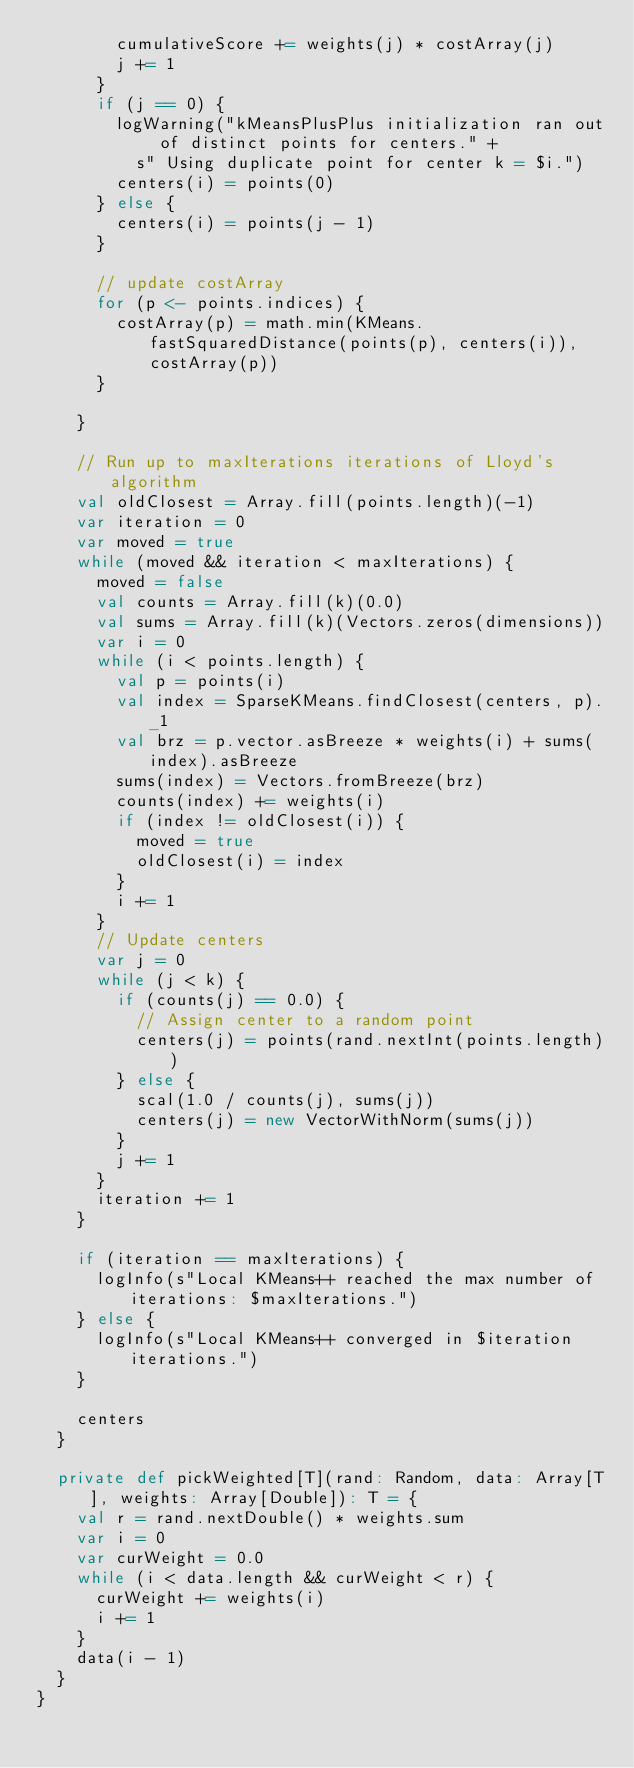<code> <loc_0><loc_0><loc_500><loc_500><_Scala_>        cumulativeScore += weights(j) * costArray(j)
        j += 1
      }
      if (j == 0) {
        logWarning("kMeansPlusPlus initialization ran out of distinct points for centers." +
          s" Using duplicate point for center k = $i.")
        centers(i) = points(0)
      } else {
        centers(i) = points(j - 1)
      }

      // update costArray
      for (p <- points.indices) {
        costArray(p) = math.min(KMeans.fastSquaredDistance(points(p), centers(i)), costArray(p))
      }

    }

    // Run up to maxIterations iterations of Lloyd's algorithm
    val oldClosest = Array.fill(points.length)(-1)
    var iteration = 0
    var moved = true
    while (moved && iteration < maxIterations) {
      moved = false
      val counts = Array.fill(k)(0.0)
      val sums = Array.fill(k)(Vectors.zeros(dimensions))
      var i = 0
      while (i < points.length) {
        val p = points(i)
        val index = SparseKMeans.findClosest(centers, p)._1
        val brz = p.vector.asBreeze * weights(i) + sums(index).asBreeze
        sums(index) = Vectors.fromBreeze(brz)
        counts(index) += weights(i)
        if (index != oldClosest(i)) {
          moved = true
          oldClosest(i) = index
        }
        i += 1
      }
      // Update centers
      var j = 0
      while (j < k) {
        if (counts(j) == 0.0) {
          // Assign center to a random point
          centers(j) = points(rand.nextInt(points.length))
        } else {
          scal(1.0 / counts(j), sums(j))
          centers(j) = new VectorWithNorm(sums(j))
        }
        j += 1
      }
      iteration += 1
    }

    if (iteration == maxIterations) {
      logInfo(s"Local KMeans++ reached the max number of iterations: $maxIterations.")
    } else {
      logInfo(s"Local KMeans++ converged in $iteration iterations.")
    }

    centers
  }

  private def pickWeighted[T](rand: Random, data: Array[T], weights: Array[Double]): T = {
    val r = rand.nextDouble() * weights.sum
    var i = 0
    var curWeight = 0.0
    while (i < data.length && curWeight < r) {
      curWeight += weights(i)
      i += 1
    }
    data(i - 1)
  }
}
</code> 